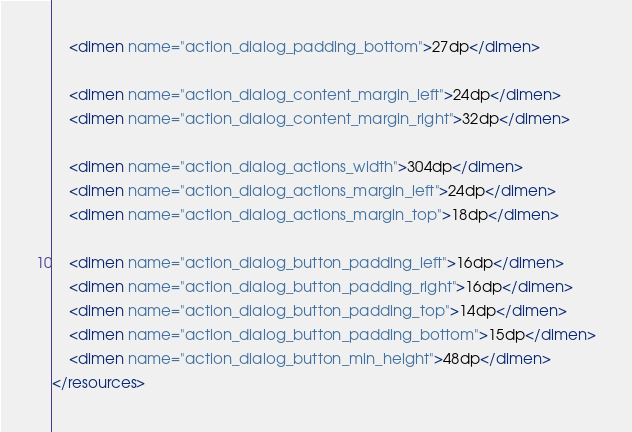Convert code to text. <code><loc_0><loc_0><loc_500><loc_500><_XML_>    <dimen name="action_dialog_padding_bottom">27dp</dimen>

    <dimen name="action_dialog_content_margin_left">24dp</dimen>
    <dimen name="action_dialog_content_margin_right">32dp</dimen>

    <dimen name="action_dialog_actions_width">304dp</dimen>
    <dimen name="action_dialog_actions_margin_left">24dp</dimen>
    <dimen name="action_dialog_actions_margin_top">18dp</dimen>

    <dimen name="action_dialog_button_padding_left">16dp</dimen>
    <dimen name="action_dialog_button_padding_right">16dp</dimen>
    <dimen name="action_dialog_button_padding_top">14dp</dimen>
    <dimen name="action_dialog_button_padding_bottom">15dp</dimen>
    <dimen name="action_dialog_button_min_height">48dp</dimen>
</resources>
</code> 